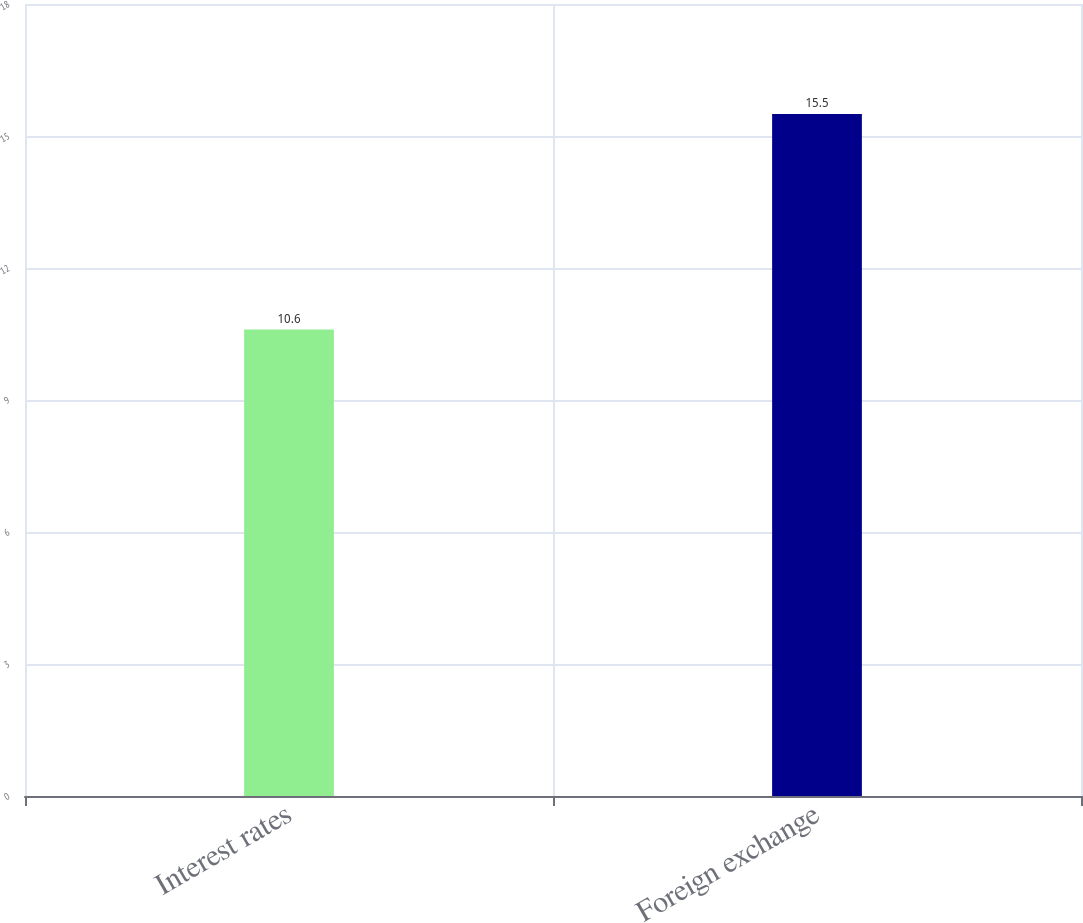<chart> <loc_0><loc_0><loc_500><loc_500><bar_chart><fcel>Interest rates<fcel>Foreign exchange<nl><fcel>10.6<fcel>15.5<nl></chart> 